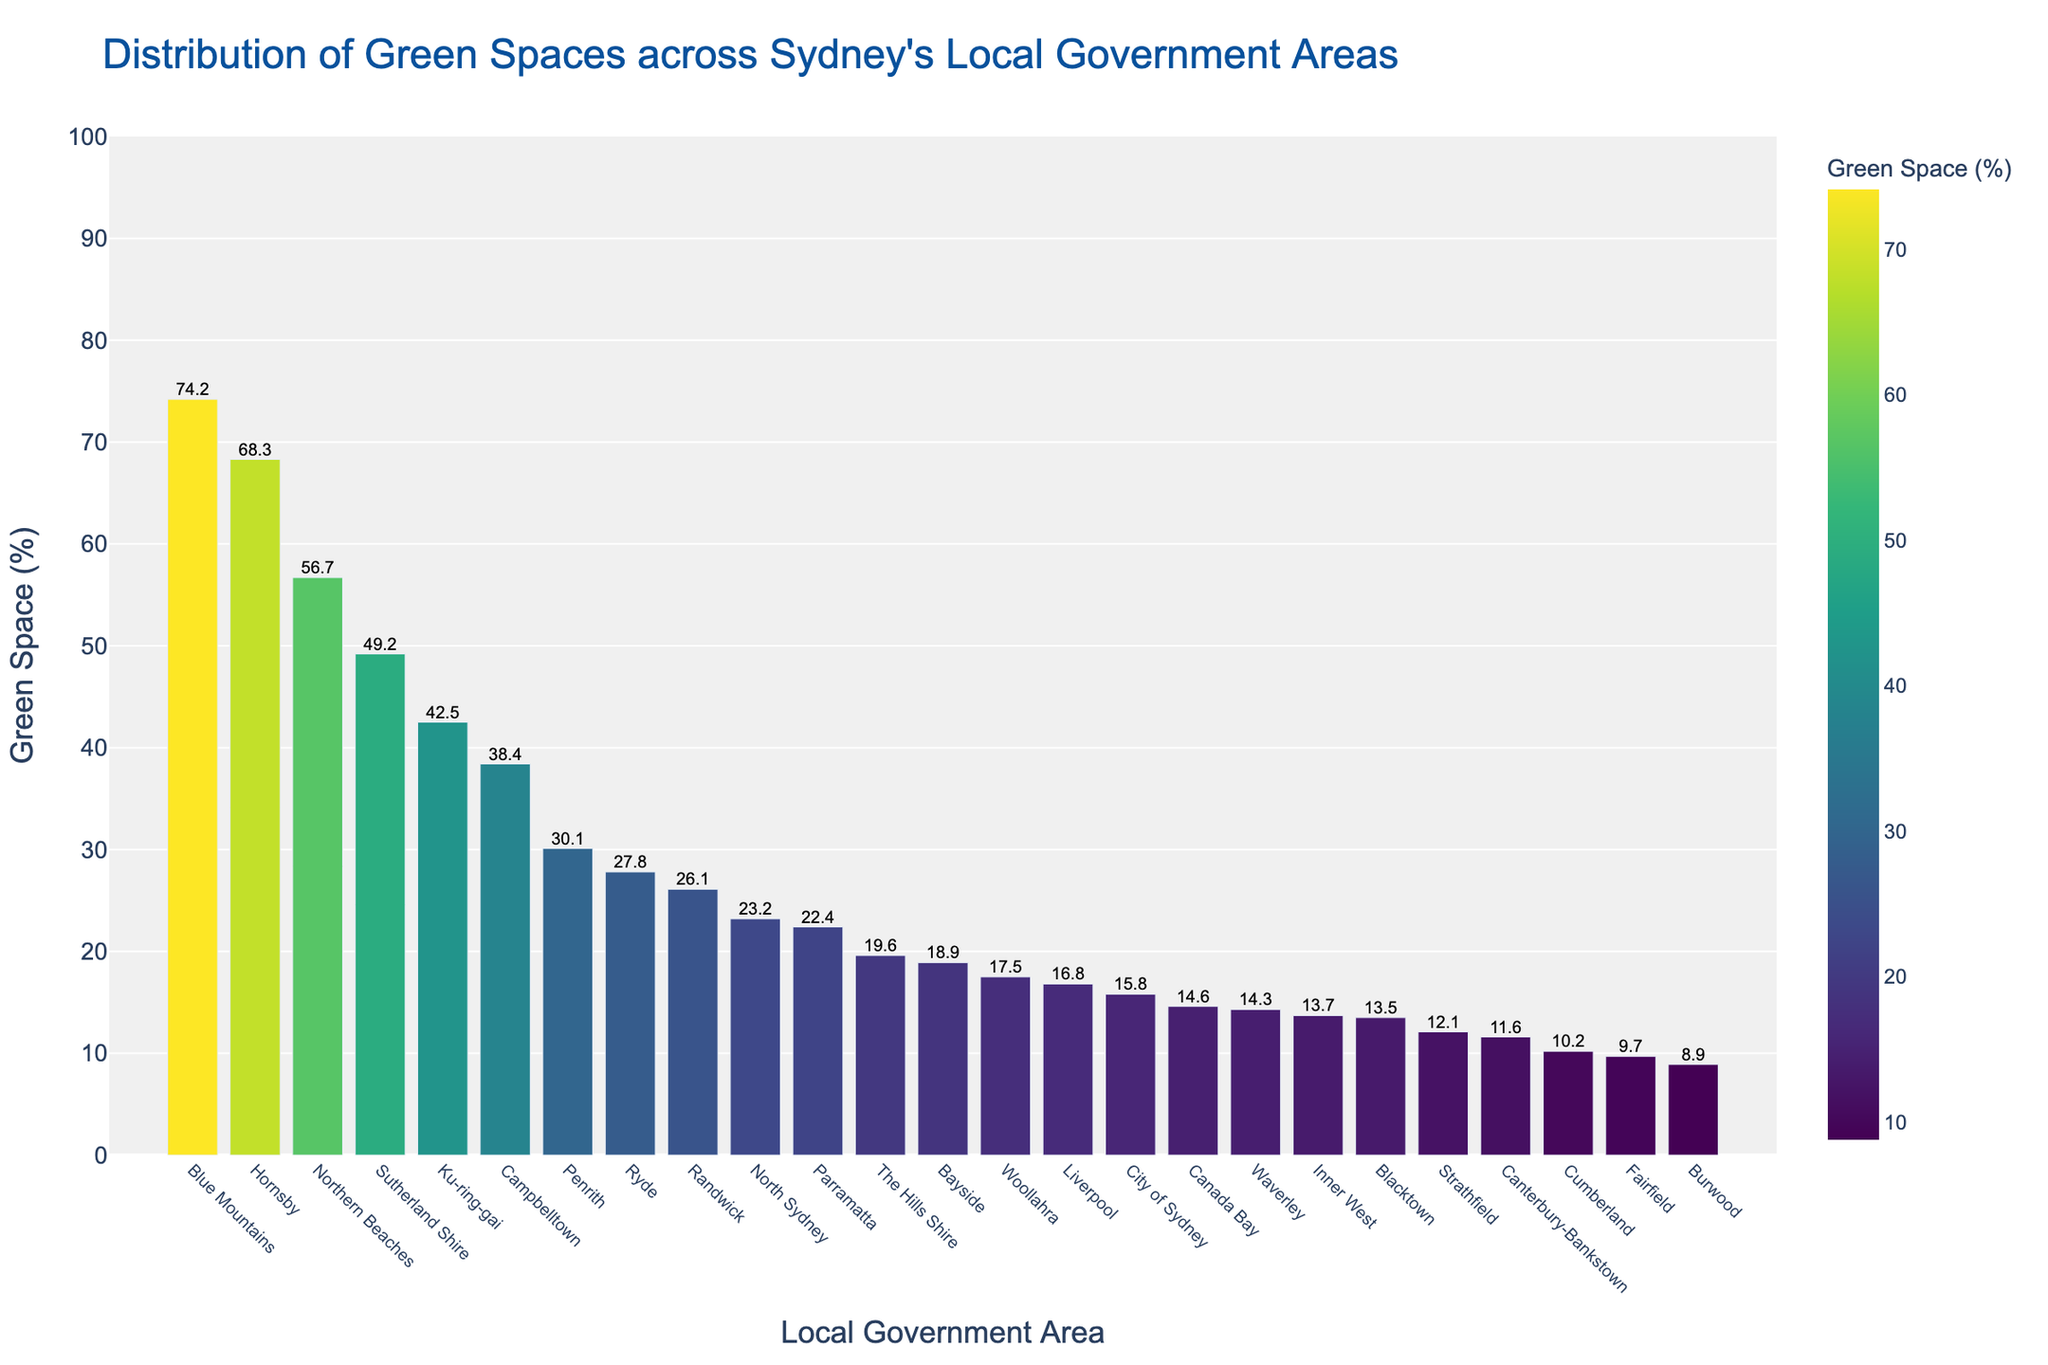Which local government area has the highest percentage of green space? Looking at the bar representing the green space percentages, the tallest bar will indicate the area with the highest percentage. The Blue Mountains has the tallest bar.
Answer: Blue Mountains Which local government area has the lowest percentage of green space? The shortest bar on the graph indicates the area with the lowest percentage of green space. Burwood has the shortest bar.
Answer: Burwood How much more green space does Ku-ring-gai have compared to City of Sydney? Ku-ring-gai's green space percentage is 42.5%, and City of Sydney's green space percentage is 15.8%: 42.5 - 15.8 = 26.7
Answer: 26.7% What is the average green space percentage of Northern Beaches, Sutherland Shire, and Blacktown? The percentages are Northern Beaches (56.7%), Sutherland Shire (49.2%), and Blacktown (13.5%): (56.7 + 49.2 + 13.5) / 3 ≈ 39.8
Answer: 39.8% Which local government area has more green space: Parramatta or Ryde? By comparing the heights of the bars for Parramatta and Ryde, Ryde's bar is taller.
Answer: Ryde What is the difference in green space percentage between Randwick and Inner West? Randwick's percentage is 26.1%, and Inner West's percentage is 13.7%: 26.1 - 13.7 = 12.4
Answer: 12.4% Are there more LGAs with green space percentages above or below 20%? Count the number of LGAs with green space percentages above and below 20%. There are 9 above and 15 below.
Answer: Below Which three LGAs have the closest green space percentages? The bars for City of Sydney (15.8%), Woollahra (17.5%), and Liverpool (16.8%) are closely matched.
Answer: City of Sydney, Woollahra, Liverpool What is the combined green space percentage of Campbelltown and Fairfield? Campbelltown has 38.4% green space and Fairfield has 9.7%: 38.4 + 9.7 = 48.1
Answer: 48.1% Is the green space percentage of Canterbury-Bankstown closer to City of Sydney or Inner West? Canterbury-Bankstown has 11.6%, City of Sydney has 15.8%, and Inner West has 13.7%. The difference with City of Sydney is 15.8 - 11.6 = 4.2, and with Inner West is 13.7 - 11.6 = 2.1.
Answer: Inner West 